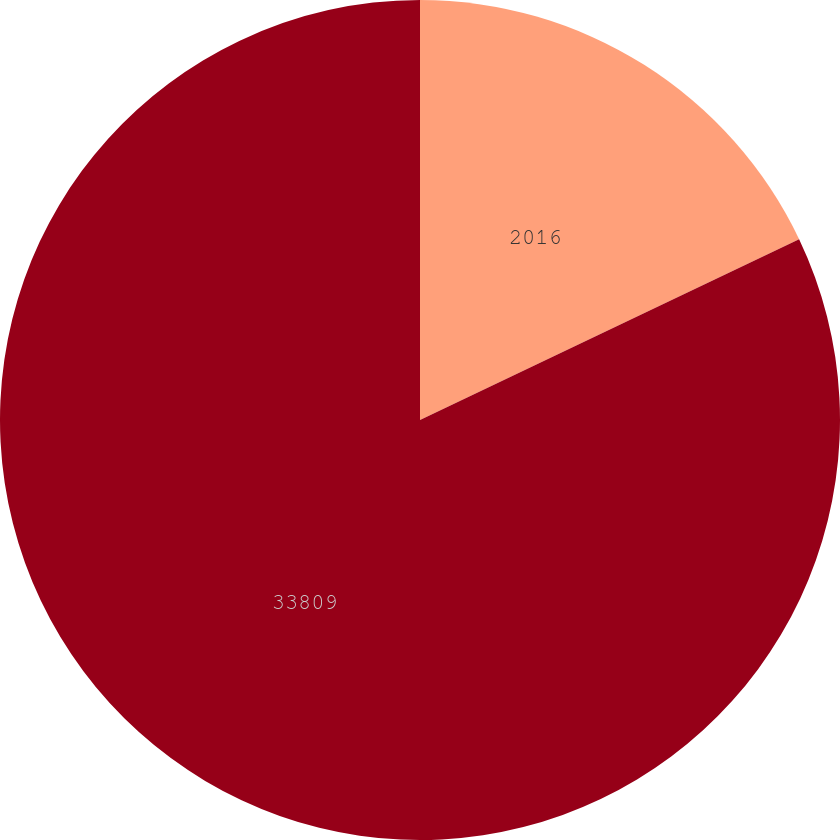Convert chart. <chart><loc_0><loc_0><loc_500><loc_500><pie_chart><fcel>2016<fcel>33809<nl><fcel>17.92%<fcel>82.08%<nl></chart> 